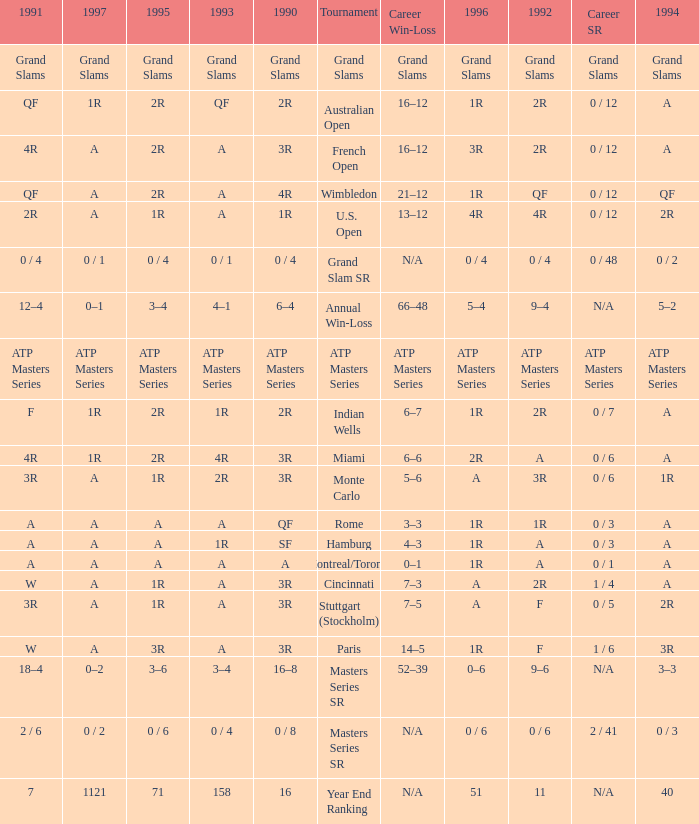What is 1996, when 1992 is "ATP Masters Series"? ATP Masters Series. 